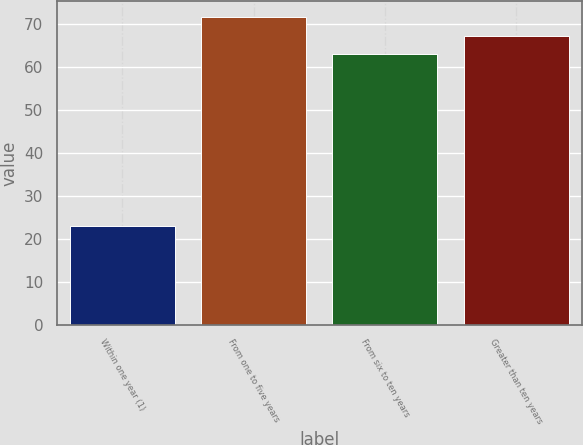Convert chart. <chart><loc_0><loc_0><loc_500><loc_500><bar_chart><fcel>Within one year (1)<fcel>From one to five years<fcel>From six to ten years<fcel>Greater than ten years<nl><fcel>23<fcel>71.8<fcel>63<fcel>67.4<nl></chart> 